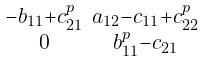Convert formula to latex. <formula><loc_0><loc_0><loc_500><loc_500>\begin{smallmatrix} - b _ { 1 1 } + c _ { 2 1 } ^ { p } & a _ { 1 2 } - c _ { 1 1 } + c _ { 2 2 } ^ { p } \\ 0 & b _ { 1 1 } ^ { p } - c _ { 2 1 } \end{smallmatrix}</formula> 